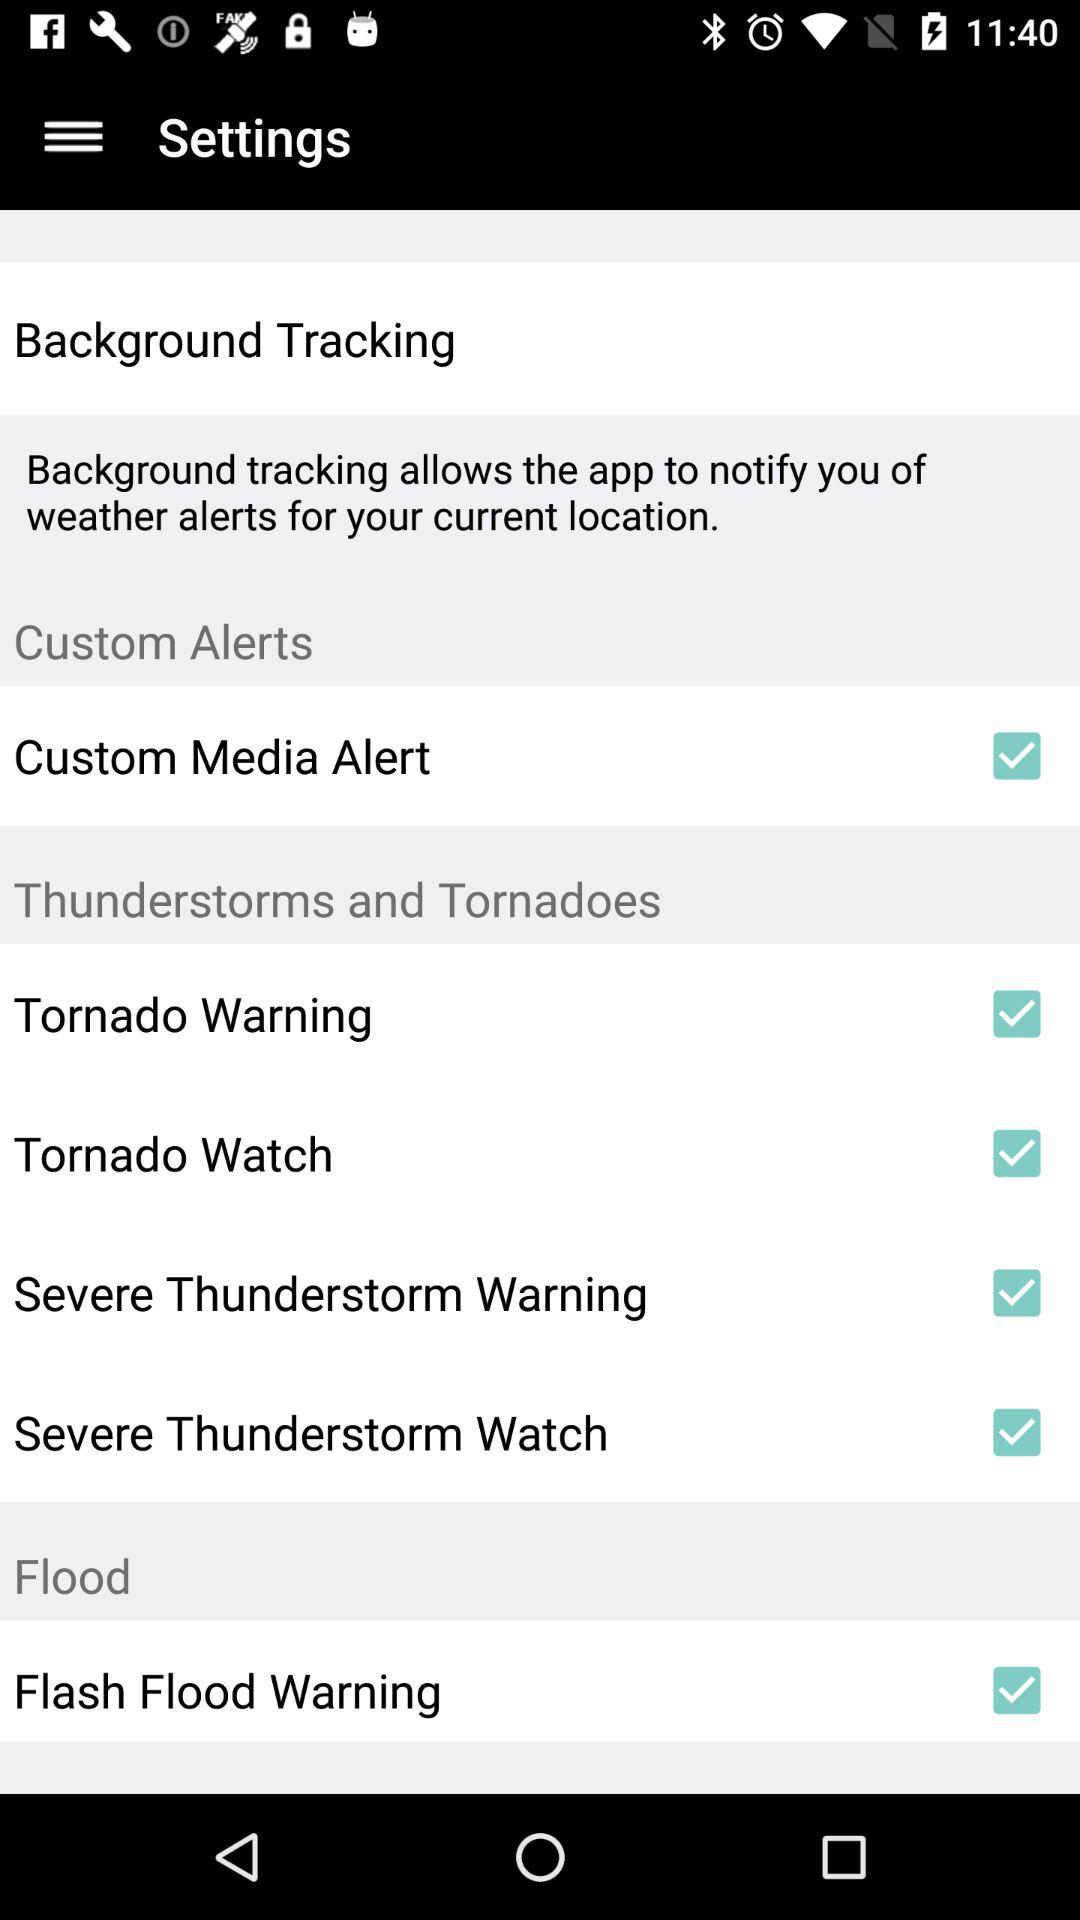Which options are checked? The checked options are "Custom Media Alert", "Tornado Warning", "Tornado Watch", "Severe Thunderstorm Warning", "Severe Thunderstorm Watch" and "Flash Flood Warning". 